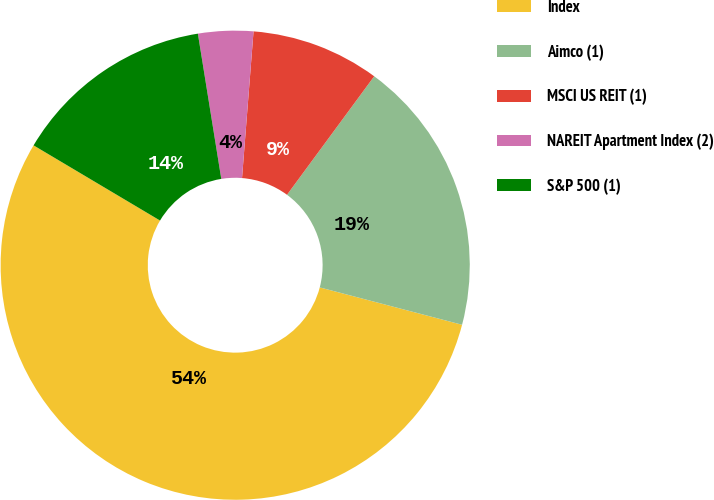Convert chart to OTSL. <chart><loc_0><loc_0><loc_500><loc_500><pie_chart><fcel>Index<fcel>Aimco (1)<fcel>MSCI US REIT (1)<fcel>NAREIT Apartment Index (2)<fcel>S&P 500 (1)<nl><fcel>54.45%<fcel>18.99%<fcel>8.85%<fcel>3.79%<fcel>13.92%<nl></chart> 